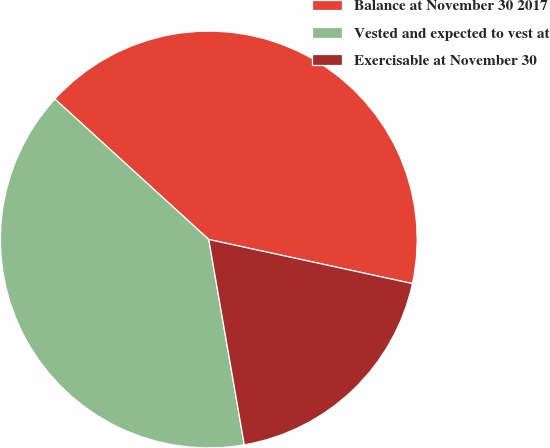Convert chart. <chart><loc_0><loc_0><loc_500><loc_500><pie_chart><fcel>Balance at November 30 2017<fcel>Vested and expected to vest at<fcel>Exercisable at November 30<nl><fcel>41.62%<fcel>39.5%<fcel>18.88%<nl></chart> 